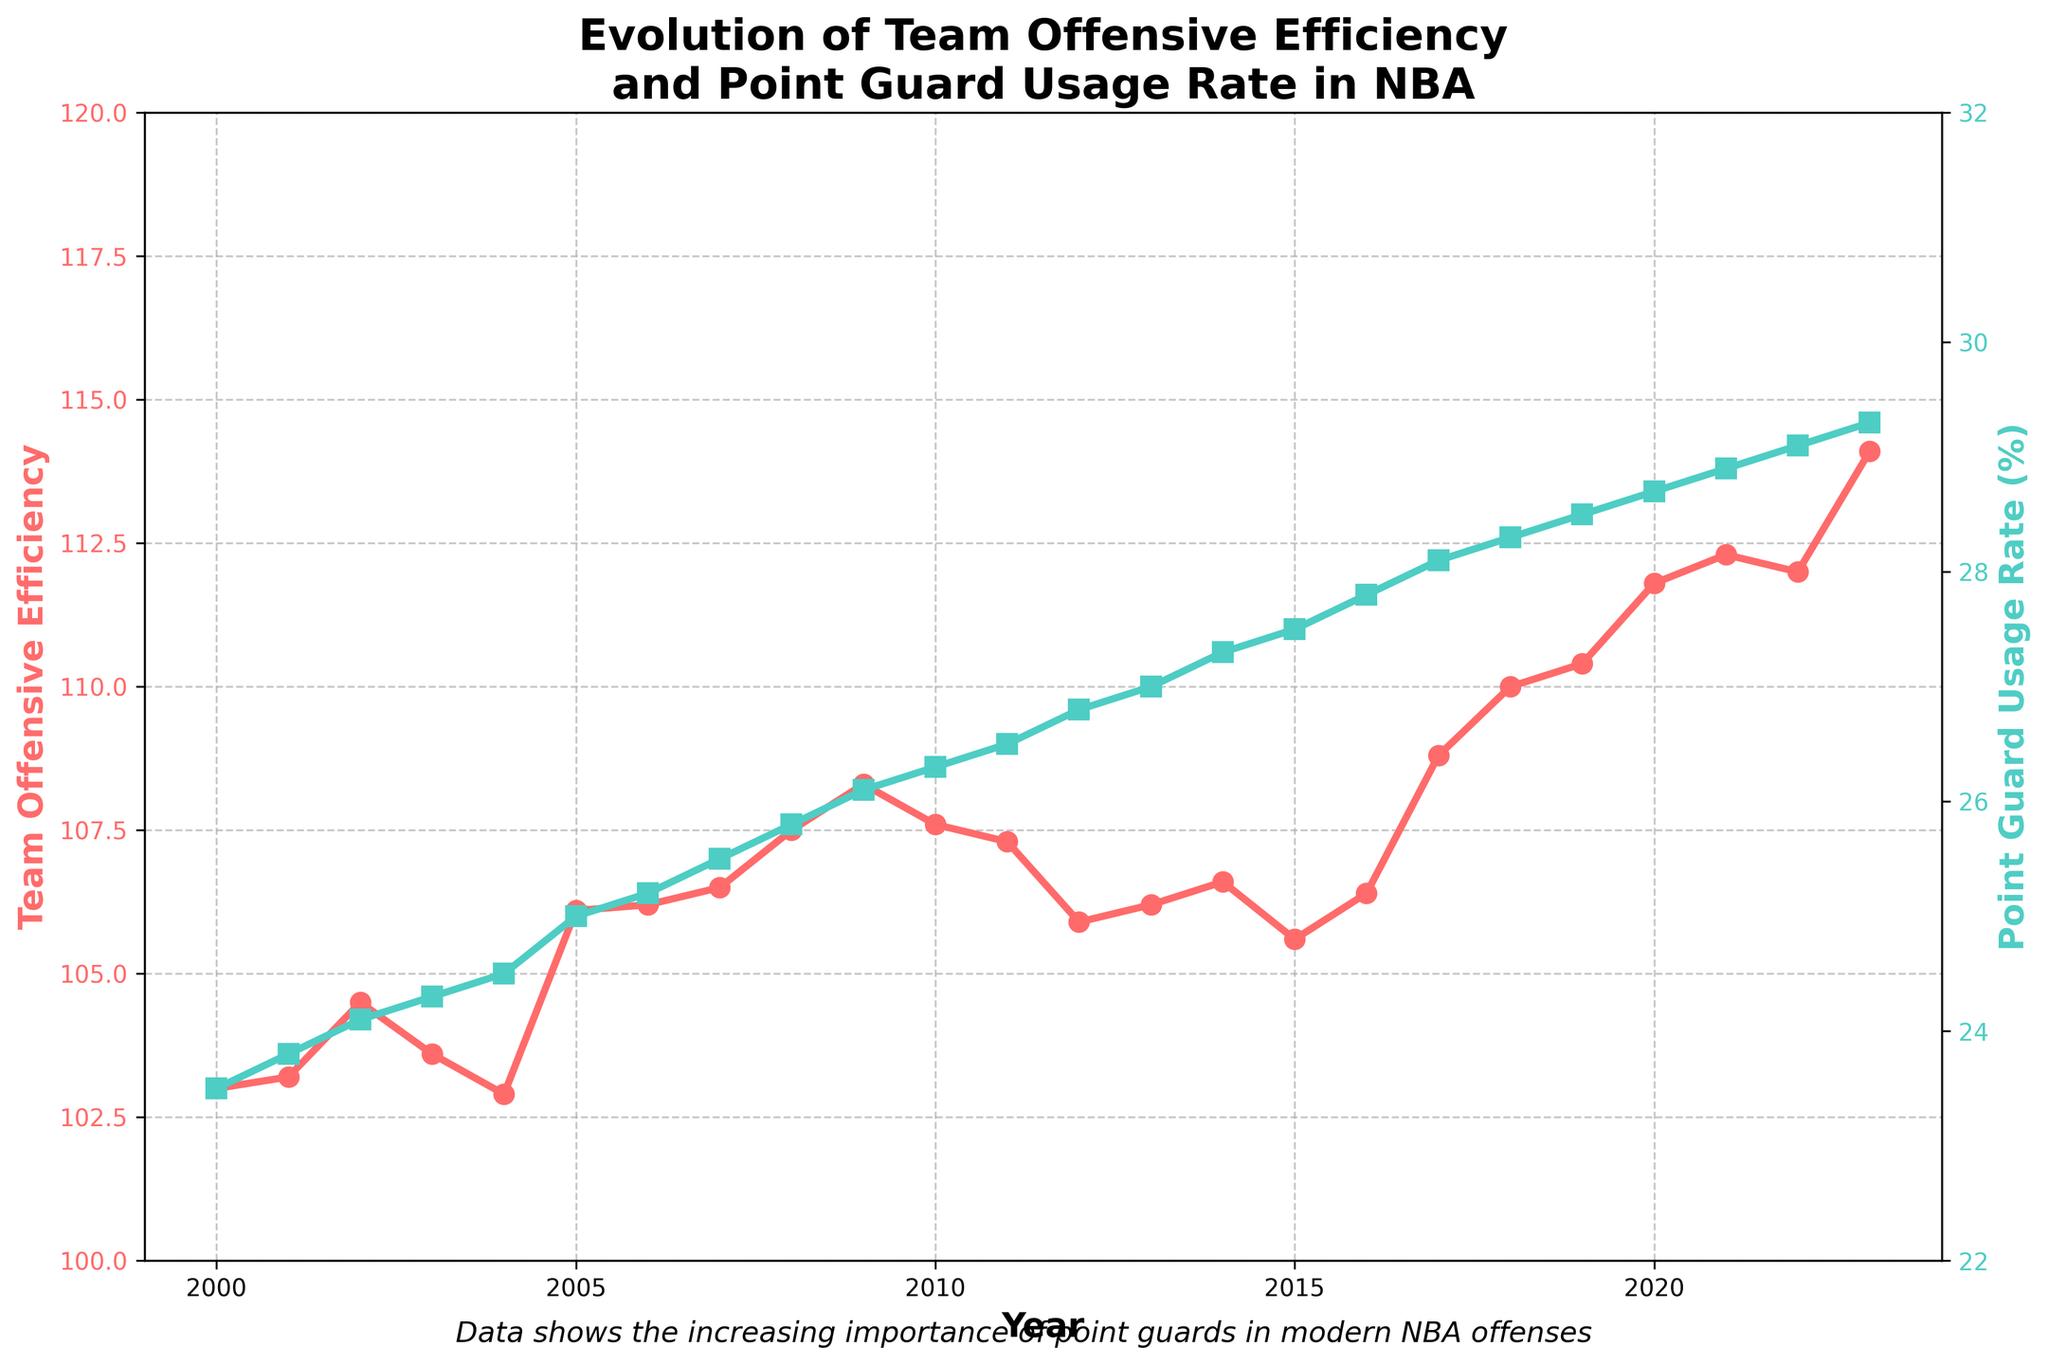What is the trend of Team Offensive Efficiency over the years? Team Offensive Efficiency generally shows an increasing trend from 2000 to 2023, rising from 103.0 to 114.1.
Answer: Increasing By how much did the Point Guard Usage Rate increase from 2000 to 2023? The Point Guard Usage Rate increased from 23.5% in 2000 to 29.3% in 2023. The difference is 29.3% - 23.5% = 5.8%.
Answer: 5.8% In which year did the Team Offensive Efficiency experience the highest value, and what was it? The highest Team Offensive Efficiency was recorded in 2023 with a value of 114.1.
Answer: 2023, 114.1 How does the Point Guard Usage Rate in 2015 compare to that in 2010? The Point Guard Usage Rate was 27.5% in 2015 and 26.3% in 2010. This shows an increase of 27.5% - 26.3% = 1.2%.
Answer: 1.2% What similarities can you observe in the trends of Team Offensive Efficiency and Point Guard Usage Rate? Both Team Offensive Efficiency and Point Guard Usage Rate show an overall increasing trend from 2000 to 2023. Both metrics have minor fluctuations but generally increase consistently over the years.
Answer: Increasing trends in both metrics Describe the change in Team Offensive Efficiency from 2009 to 2012. In 2009, the Team Offensive Efficiency was 108.3, and by 2012, it had decreased to 105.9, showing a reduction.
Answer: Decreased from 108.3 to 105.9 Which color represents the Point Guard Usage Rate, and what is its trend direction over the years? The Point Guard Usage Rate is represented by a green line, and its trend direction is increasing over the years.
Answer: Green, increasing In which years did the Team Offensive Efficiency increase despite a decrease in Point Guard Usage Rate? There are no years indicated in the data where Team Offensive Efficiency increased while Point Guard Usage Rate decreased.
Answer: None By how much did the Team Offensive Efficiency increase between 2017 and 2020? The Team Offensive Efficiency increased from 108.8 in 2017 to 111.8 in 2020. The difference is 111.8 - 108.8 = 3.0.
Answer: 3.0 Which year's data point suggests that the Team Offensive Efficiency and Point Guard Usage Rate both increased the most simultaneously? The year 2023 shows both the highest Team Offensive Efficiency (114.1) and Point Guard Usage Rate (29.3), suggesting the most simultaneous increase.
Answer: 2023 